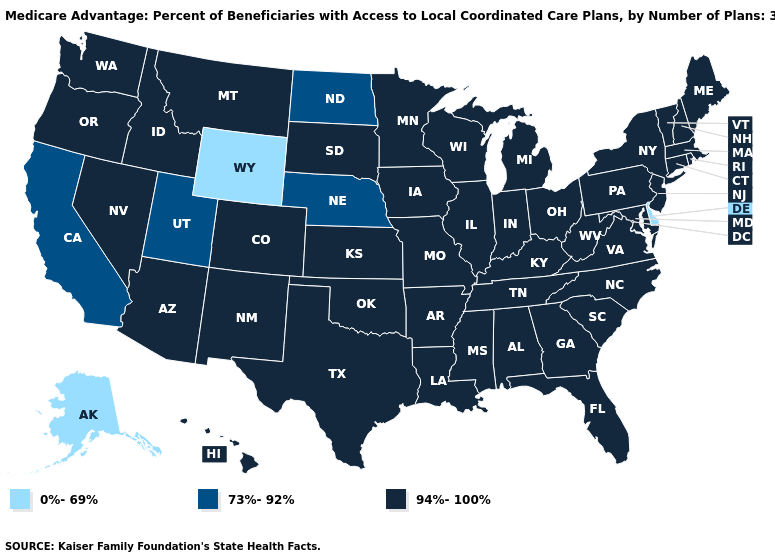What is the lowest value in the Northeast?
Quick response, please. 94%-100%. What is the value of Virginia?
Be succinct. 94%-100%. Name the states that have a value in the range 94%-100%?
Quick response, please. Colorado, Connecticut, Florida, Georgia, Hawaii, Iowa, Idaho, Illinois, Indiana, Kansas, Kentucky, Louisiana, Massachusetts, Maryland, Maine, Michigan, Minnesota, Missouri, Mississippi, Montana, North Carolina, New Hampshire, New Jersey, New Mexico, Nevada, New York, Ohio, Oklahoma, Oregon, Pennsylvania, Rhode Island, South Carolina, South Dakota, Tennessee, Texas, Virginia, Vermont, Washington, Wisconsin, West Virginia, Alabama, Arkansas, Arizona. Which states have the lowest value in the USA?
Answer briefly. Delaware, Alaska, Wyoming. Does South Carolina have the lowest value in the USA?
Quick response, please. No. What is the highest value in the Northeast ?
Be succinct. 94%-100%. Does the map have missing data?
Answer briefly. No. How many symbols are there in the legend?
Give a very brief answer. 3. Among the states that border New Jersey , does New York have the lowest value?
Give a very brief answer. No. Does the first symbol in the legend represent the smallest category?
Answer briefly. Yes. Name the states that have a value in the range 73%-92%?
Concise answer only. California, North Dakota, Nebraska, Utah. Name the states that have a value in the range 0%-69%?
Give a very brief answer. Delaware, Alaska, Wyoming. Does Montana have the highest value in the West?
Be succinct. Yes. 